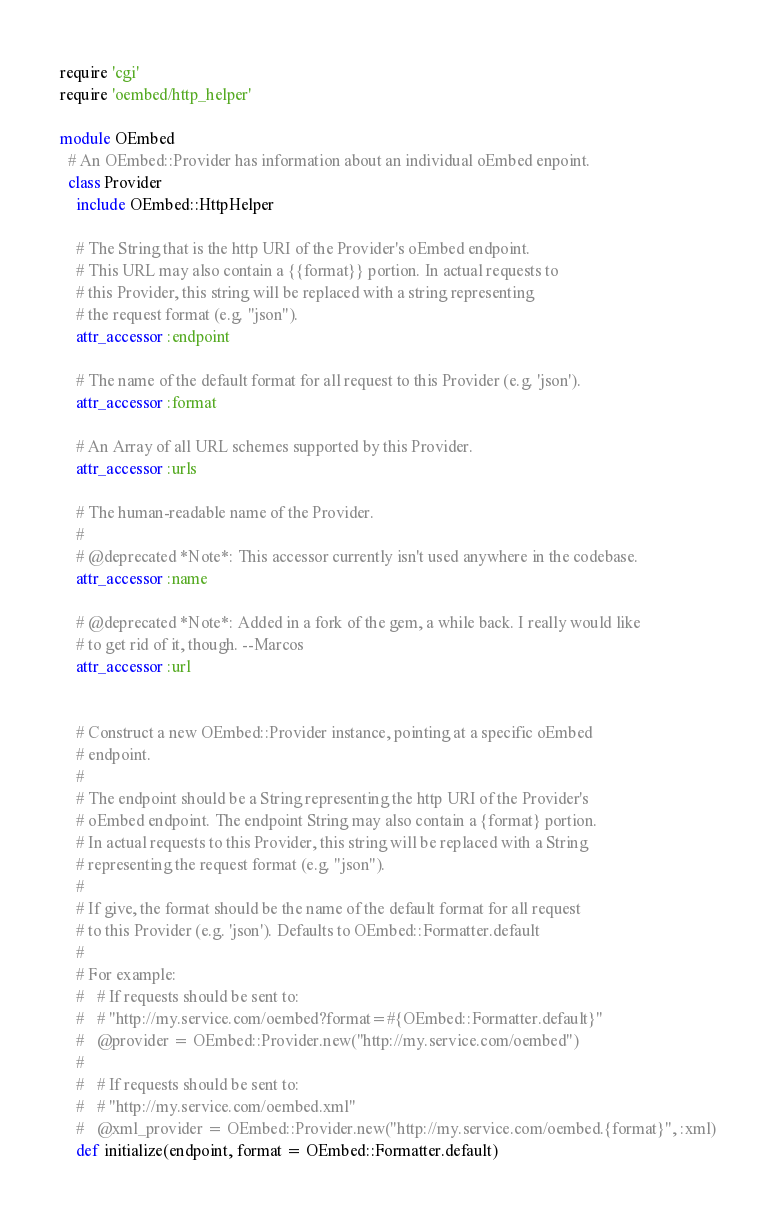<code> <loc_0><loc_0><loc_500><loc_500><_Ruby_>require 'cgi'
require 'oembed/http_helper'

module OEmbed
  # An OEmbed::Provider has information about an individual oEmbed enpoint.
  class Provider
    include OEmbed::HttpHelper

    # The String that is the http URI of the Provider's oEmbed endpoint.
    # This URL may also contain a {{format}} portion. In actual requests to
    # this Provider, this string will be replaced with a string representing
    # the request format (e.g. "json").
    attr_accessor :endpoint

    # The name of the default format for all request to this Provider (e.g. 'json').
    attr_accessor :format

    # An Array of all URL schemes supported by this Provider.
    attr_accessor :urls

    # The human-readable name of the Provider.
    #
    # @deprecated *Note*: This accessor currently isn't used anywhere in the codebase.
    attr_accessor :name

    # @deprecated *Note*: Added in a fork of the gem, a while back. I really would like
    # to get rid of it, though. --Marcos
    attr_accessor :url


    # Construct a new OEmbed::Provider instance, pointing at a specific oEmbed
    # endpoint.
    #
    # The endpoint should be a String representing the http URI of the Provider's
    # oEmbed endpoint. The endpoint String may also contain a {format} portion.
    # In actual requests to this Provider, this string will be replaced with a String
    # representing the request format (e.g. "json").
    #
    # If give, the format should be the name of the default format for all request
    # to this Provider (e.g. 'json'). Defaults to OEmbed::Formatter.default
    #
    # For example:
    #   # If requests should be sent to:
    #   # "http://my.service.com/oembed?format=#{OEmbed::Formatter.default}"
    #   @provider = OEmbed::Provider.new("http://my.service.com/oembed")
    #
    #   # If requests should be sent to:
    #   # "http://my.service.com/oembed.xml"
    #   @xml_provider = OEmbed::Provider.new("http://my.service.com/oembed.{format}", :xml)
    def initialize(endpoint, format = OEmbed::Formatter.default)</code> 